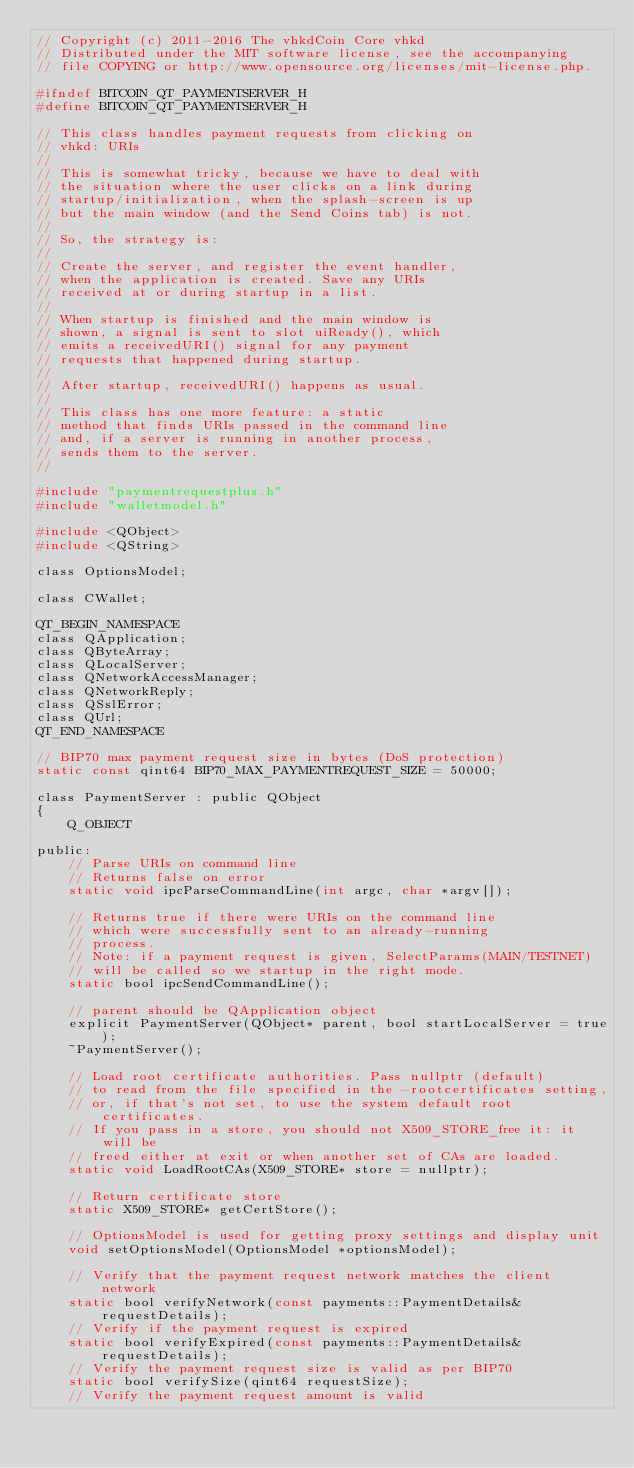Convert code to text. <code><loc_0><loc_0><loc_500><loc_500><_C_>// Copyright (c) 2011-2016 The vhkdCoin Core vhkd
// Distributed under the MIT software license, see the accompanying
// file COPYING or http://www.opensource.org/licenses/mit-license.php.

#ifndef BITCOIN_QT_PAYMENTSERVER_H
#define BITCOIN_QT_PAYMENTSERVER_H

// This class handles payment requests from clicking on
// vhkd: URIs
//
// This is somewhat tricky, because we have to deal with
// the situation where the user clicks on a link during
// startup/initialization, when the splash-screen is up
// but the main window (and the Send Coins tab) is not.
//
// So, the strategy is:
//
// Create the server, and register the event handler,
// when the application is created. Save any URIs
// received at or during startup in a list.
//
// When startup is finished and the main window is
// shown, a signal is sent to slot uiReady(), which
// emits a receivedURI() signal for any payment
// requests that happened during startup.
//
// After startup, receivedURI() happens as usual.
//
// This class has one more feature: a static
// method that finds URIs passed in the command line
// and, if a server is running in another process,
// sends them to the server.
//

#include "paymentrequestplus.h"
#include "walletmodel.h"

#include <QObject>
#include <QString>

class OptionsModel;

class CWallet;

QT_BEGIN_NAMESPACE
class QApplication;
class QByteArray;
class QLocalServer;
class QNetworkAccessManager;
class QNetworkReply;
class QSslError;
class QUrl;
QT_END_NAMESPACE

// BIP70 max payment request size in bytes (DoS protection)
static const qint64 BIP70_MAX_PAYMENTREQUEST_SIZE = 50000;

class PaymentServer : public QObject
{
    Q_OBJECT

public:
    // Parse URIs on command line
    // Returns false on error
    static void ipcParseCommandLine(int argc, char *argv[]);

    // Returns true if there were URIs on the command line
    // which were successfully sent to an already-running
    // process.
    // Note: if a payment request is given, SelectParams(MAIN/TESTNET)
    // will be called so we startup in the right mode.
    static bool ipcSendCommandLine();

    // parent should be QApplication object
    explicit PaymentServer(QObject* parent, bool startLocalServer = true);
    ~PaymentServer();

    // Load root certificate authorities. Pass nullptr (default)
    // to read from the file specified in the -rootcertificates setting,
    // or, if that's not set, to use the system default root certificates.
    // If you pass in a store, you should not X509_STORE_free it: it will be
    // freed either at exit or when another set of CAs are loaded.
    static void LoadRootCAs(X509_STORE* store = nullptr);

    // Return certificate store
    static X509_STORE* getCertStore();

    // OptionsModel is used for getting proxy settings and display unit
    void setOptionsModel(OptionsModel *optionsModel);

    // Verify that the payment request network matches the client network
    static bool verifyNetwork(const payments::PaymentDetails& requestDetails);
    // Verify if the payment request is expired
    static bool verifyExpired(const payments::PaymentDetails& requestDetails);
    // Verify the payment request size is valid as per BIP70
    static bool verifySize(qint64 requestSize);
    // Verify the payment request amount is valid</code> 